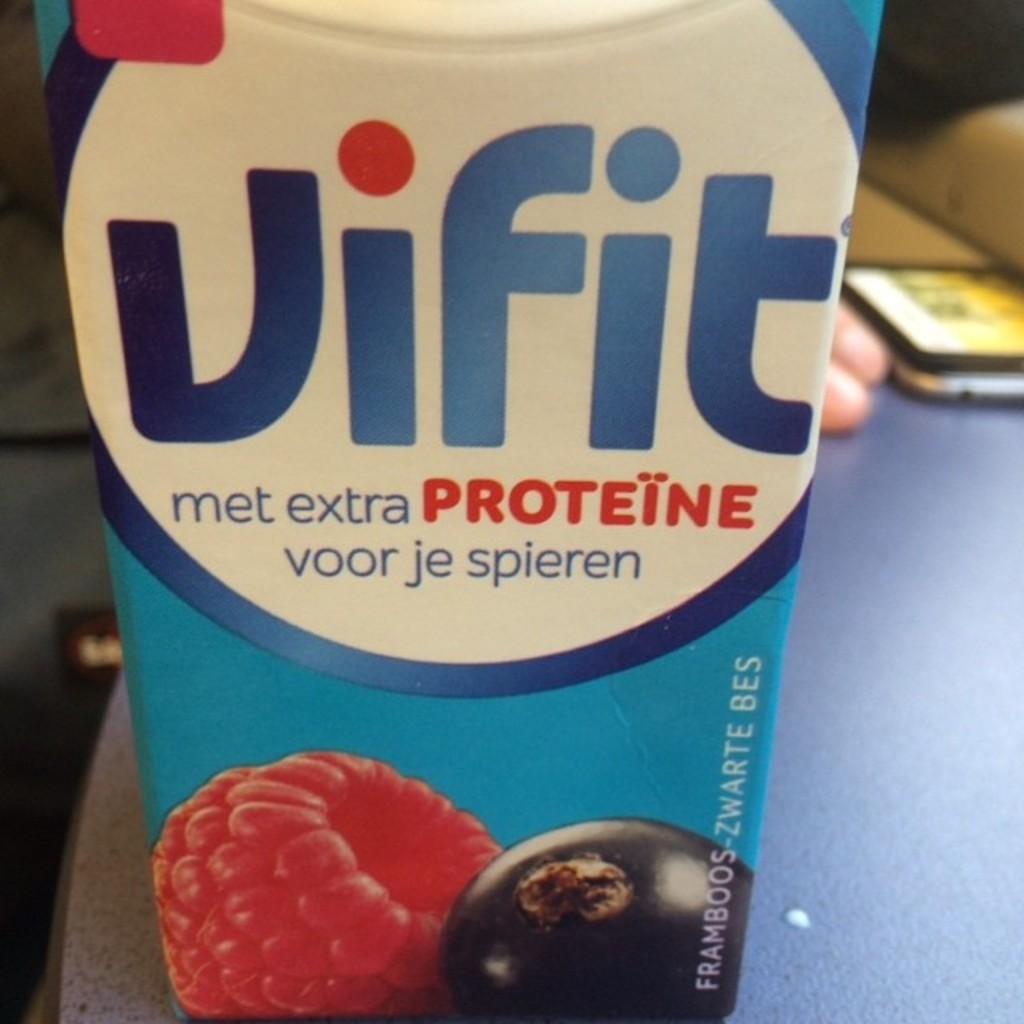What drink brand is this?
Your response must be concise. Vifit. What essential chemical does the juice contain?
Provide a short and direct response. Proteine. 